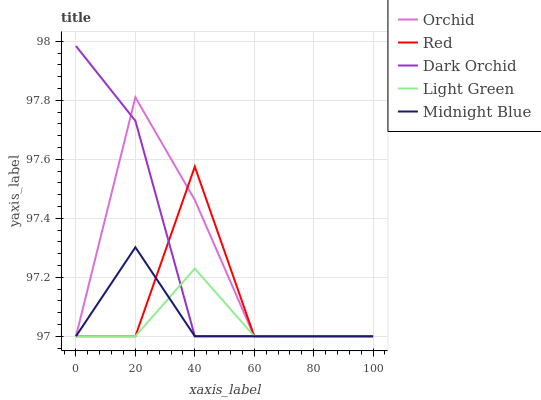Does Dark Orchid have the minimum area under the curve?
Answer yes or no. No. Does Dark Orchid have the maximum area under the curve?
Answer yes or no. No. Is Light Green the smoothest?
Answer yes or no. No. Is Light Green the roughest?
Answer yes or no. No. Does Light Green have the highest value?
Answer yes or no. No. 